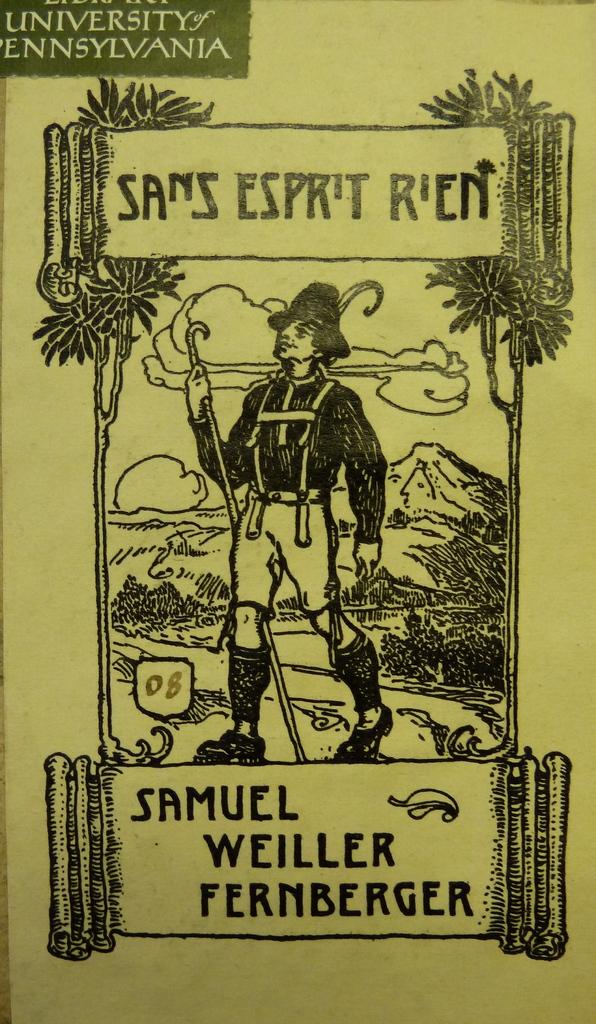Who is the author of this?
Offer a very short reply. Samuel weiller fernberger. What university is in the picture?
Give a very brief answer. University of pennsylvania. 